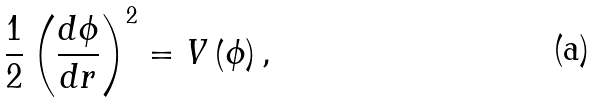<formula> <loc_0><loc_0><loc_500><loc_500>\frac { 1 } { 2 } \left ( \frac { d \phi } { d r } \right ) ^ { 2 } = V \left ( \phi \right ) ,</formula> 